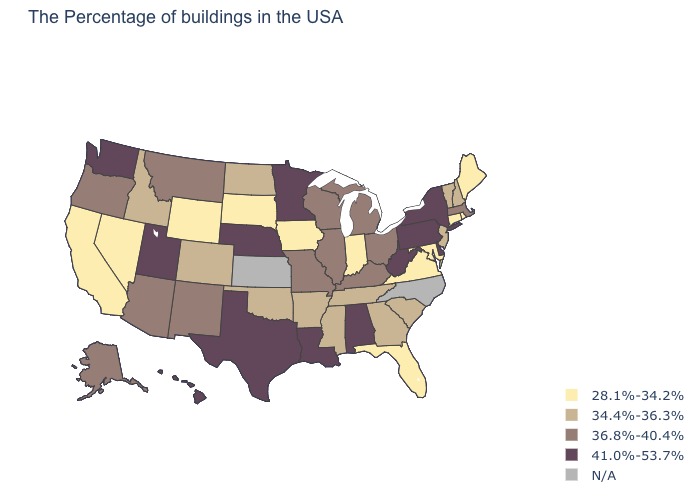What is the highest value in states that border North Carolina?
Write a very short answer. 34.4%-36.3%. Which states hav the highest value in the West?
Give a very brief answer. Utah, Washington, Hawaii. Which states have the lowest value in the MidWest?
Keep it brief. Indiana, Iowa, South Dakota. Name the states that have a value in the range 36.8%-40.4%?
Write a very short answer. Massachusetts, Ohio, Michigan, Kentucky, Wisconsin, Illinois, Missouri, New Mexico, Montana, Arizona, Oregon, Alaska. How many symbols are there in the legend?
Short answer required. 5. Does Maine have the lowest value in the Northeast?
Answer briefly. Yes. Does the first symbol in the legend represent the smallest category?
Quick response, please. Yes. Does the first symbol in the legend represent the smallest category?
Answer briefly. Yes. Does the map have missing data?
Answer briefly. Yes. What is the value of Maryland?
Be succinct. 28.1%-34.2%. What is the highest value in the Northeast ?
Concise answer only. 41.0%-53.7%. Does the map have missing data?
Keep it brief. Yes. What is the value of Arkansas?
Write a very short answer. 34.4%-36.3%. Name the states that have a value in the range N/A?
Keep it brief. North Carolina, Kansas. 